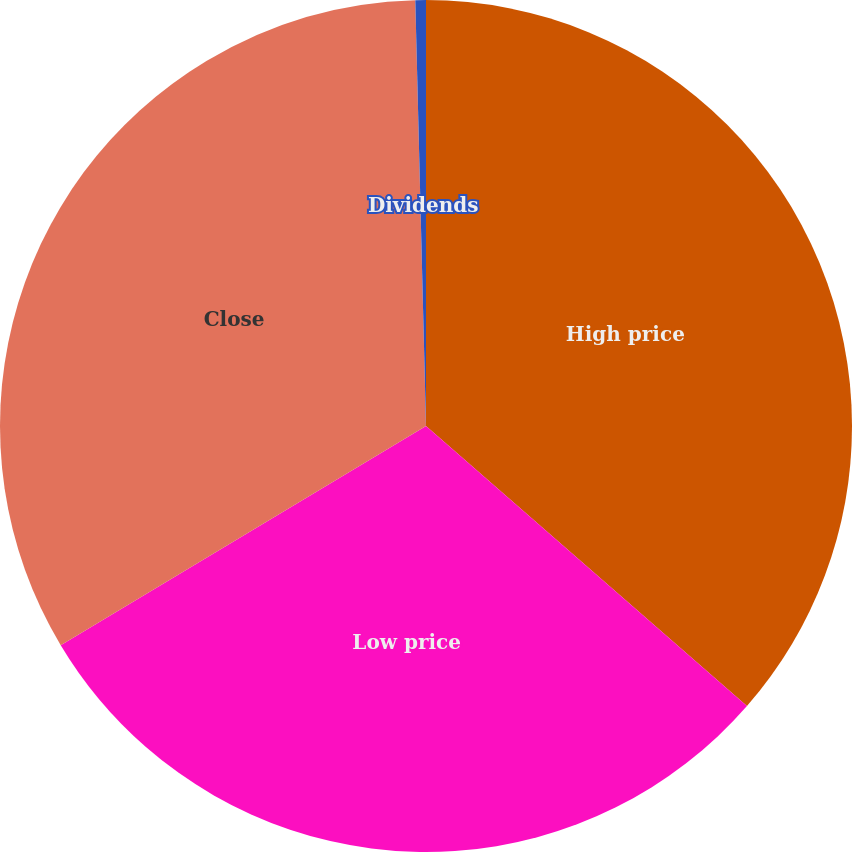Convert chart. <chart><loc_0><loc_0><loc_500><loc_500><pie_chart><fcel>High price<fcel>Low price<fcel>Close<fcel>Dividends<nl><fcel>36.42%<fcel>29.98%<fcel>33.2%<fcel>0.4%<nl></chart> 